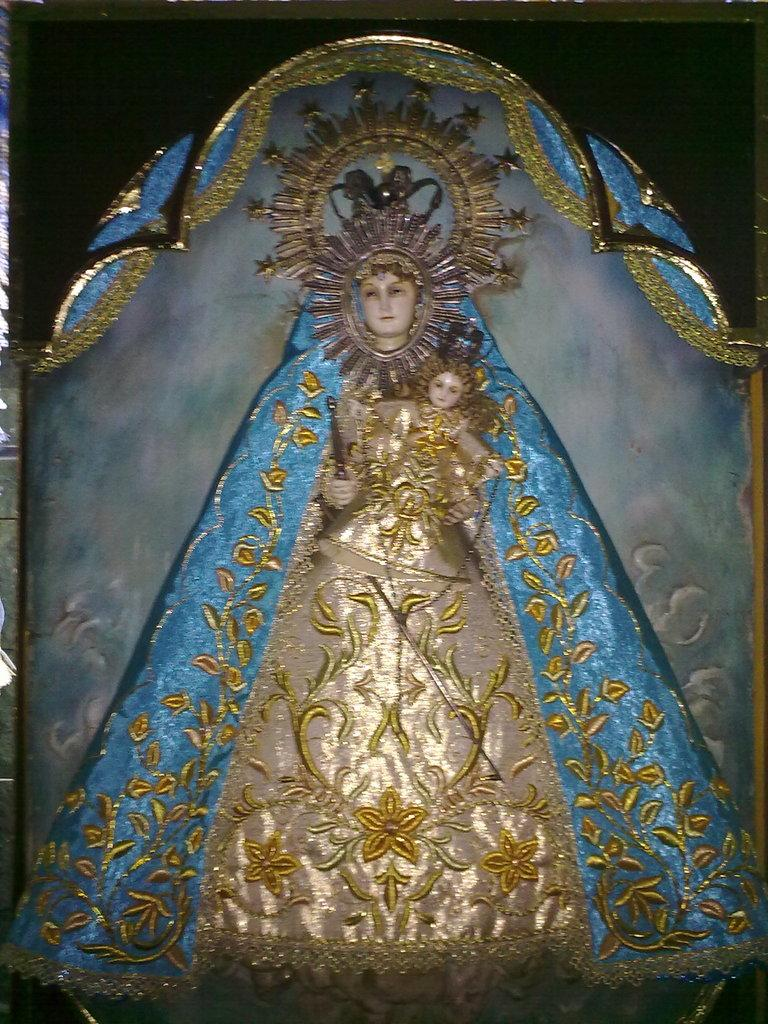What is the main subject of the image? The main subject of the image is a statue of a woman. What is the woman in the statue doing? The woman is holding a baby in the statue. How is the statue decorated? The statue is covered with blue and gold color clothes. What type of collar can be seen on the baby in the image? There is no collar visible on the baby in the image, as it is a statue and not a real baby. 